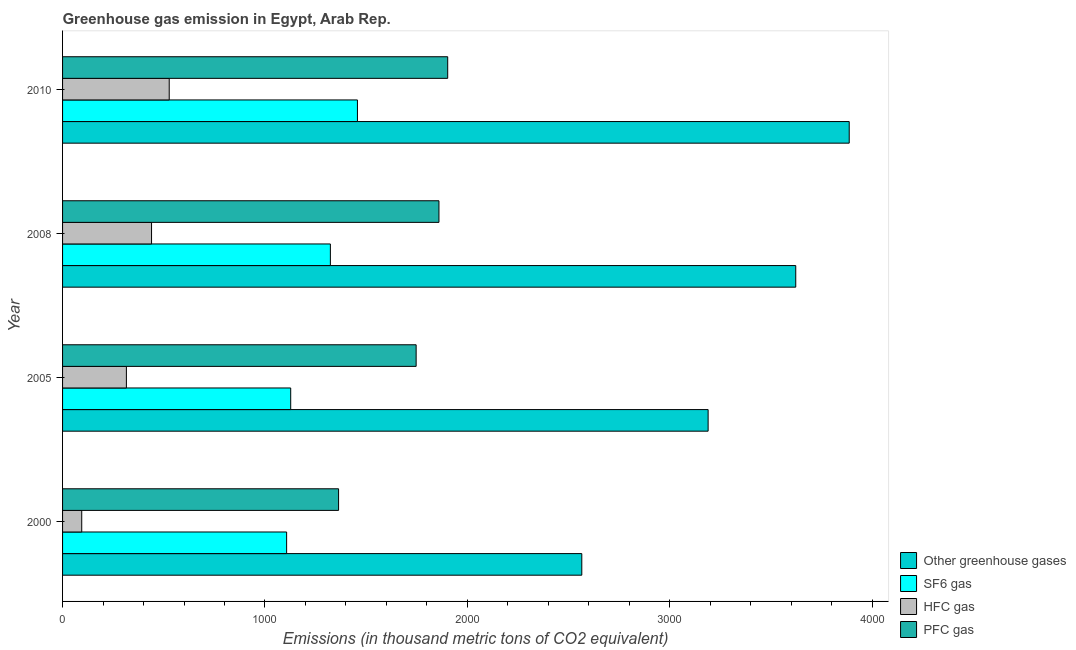How many different coloured bars are there?
Offer a terse response. 4. How many groups of bars are there?
Offer a terse response. 4. Are the number of bars per tick equal to the number of legend labels?
Provide a succinct answer. Yes. How many bars are there on the 1st tick from the top?
Your answer should be compact. 4. What is the label of the 3rd group of bars from the top?
Your answer should be compact. 2005. In how many cases, is the number of bars for a given year not equal to the number of legend labels?
Offer a very short reply. 0. What is the emission of greenhouse gases in 2010?
Make the answer very short. 3887. Across all years, what is the maximum emission of pfc gas?
Provide a short and direct response. 1903. Across all years, what is the minimum emission of greenhouse gases?
Offer a terse response. 2565.6. In which year was the emission of hfc gas maximum?
Ensure brevity in your answer.  2010. What is the total emission of sf6 gas in the graph?
Make the answer very short. 5014.7. What is the difference between the emission of greenhouse gases in 2008 and that in 2010?
Give a very brief answer. -264.2. What is the difference between the emission of greenhouse gases in 2010 and the emission of pfc gas in 2008?
Give a very brief answer. 2027.2. What is the average emission of sf6 gas per year?
Provide a short and direct response. 1253.67. In the year 2005, what is the difference between the emission of hfc gas and emission of sf6 gas?
Keep it short and to the point. -811.9. In how many years, is the emission of greenhouse gases greater than 400 thousand metric tons?
Offer a terse response. 4. What is the ratio of the emission of hfc gas in 2000 to that in 2005?
Offer a terse response. 0.3. What is the difference between the highest and the second highest emission of greenhouse gases?
Keep it short and to the point. 264.2. What is the difference between the highest and the lowest emission of pfc gas?
Ensure brevity in your answer.  539.2. Is the sum of the emission of pfc gas in 2005 and 2008 greater than the maximum emission of sf6 gas across all years?
Your answer should be compact. Yes. Is it the case that in every year, the sum of the emission of greenhouse gases and emission of pfc gas is greater than the sum of emission of hfc gas and emission of sf6 gas?
Offer a terse response. Yes. What does the 4th bar from the top in 2000 represents?
Your answer should be compact. Other greenhouse gases. What does the 2nd bar from the bottom in 2005 represents?
Make the answer very short. SF6 gas. Are all the bars in the graph horizontal?
Your response must be concise. Yes. How many years are there in the graph?
Offer a terse response. 4. Are the values on the major ticks of X-axis written in scientific E-notation?
Provide a short and direct response. No. How are the legend labels stacked?
Your answer should be very brief. Vertical. What is the title of the graph?
Give a very brief answer. Greenhouse gas emission in Egypt, Arab Rep. What is the label or title of the X-axis?
Offer a terse response. Emissions (in thousand metric tons of CO2 equivalent). What is the Emissions (in thousand metric tons of CO2 equivalent) in Other greenhouse gases in 2000?
Make the answer very short. 2565.6. What is the Emissions (in thousand metric tons of CO2 equivalent) in SF6 gas in 2000?
Offer a very short reply. 1107.1. What is the Emissions (in thousand metric tons of CO2 equivalent) of HFC gas in 2000?
Make the answer very short. 94.7. What is the Emissions (in thousand metric tons of CO2 equivalent) in PFC gas in 2000?
Offer a terse response. 1363.8. What is the Emissions (in thousand metric tons of CO2 equivalent) in Other greenhouse gases in 2005?
Provide a short and direct response. 3189.8. What is the Emissions (in thousand metric tons of CO2 equivalent) of SF6 gas in 2005?
Your answer should be compact. 1127.3. What is the Emissions (in thousand metric tons of CO2 equivalent) of HFC gas in 2005?
Your answer should be compact. 315.4. What is the Emissions (in thousand metric tons of CO2 equivalent) in PFC gas in 2005?
Keep it short and to the point. 1747.1. What is the Emissions (in thousand metric tons of CO2 equivalent) of Other greenhouse gases in 2008?
Keep it short and to the point. 3622.8. What is the Emissions (in thousand metric tons of CO2 equivalent) of SF6 gas in 2008?
Offer a very short reply. 1323.3. What is the Emissions (in thousand metric tons of CO2 equivalent) in HFC gas in 2008?
Offer a terse response. 439.7. What is the Emissions (in thousand metric tons of CO2 equivalent) in PFC gas in 2008?
Offer a terse response. 1859.8. What is the Emissions (in thousand metric tons of CO2 equivalent) in Other greenhouse gases in 2010?
Keep it short and to the point. 3887. What is the Emissions (in thousand metric tons of CO2 equivalent) of SF6 gas in 2010?
Ensure brevity in your answer.  1457. What is the Emissions (in thousand metric tons of CO2 equivalent) of HFC gas in 2010?
Give a very brief answer. 527. What is the Emissions (in thousand metric tons of CO2 equivalent) of PFC gas in 2010?
Provide a succinct answer. 1903. Across all years, what is the maximum Emissions (in thousand metric tons of CO2 equivalent) in Other greenhouse gases?
Keep it short and to the point. 3887. Across all years, what is the maximum Emissions (in thousand metric tons of CO2 equivalent) of SF6 gas?
Make the answer very short. 1457. Across all years, what is the maximum Emissions (in thousand metric tons of CO2 equivalent) of HFC gas?
Provide a succinct answer. 527. Across all years, what is the maximum Emissions (in thousand metric tons of CO2 equivalent) of PFC gas?
Keep it short and to the point. 1903. Across all years, what is the minimum Emissions (in thousand metric tons of CO2 equivalent) in Other greenhouse gases?
Give a very brief answer. 2565.6. Across all years, what is the minimum Emissions (in thousand metric tons of CO2 equivalent) in SF6 gas?
Your answer should be very brief. 1107.1. Across all years, what is the minimum Emissions (in thousand metric tons of CO2 equivalent) of HFC gas?
Provide a succinct answer. 94.7. Across all years, what is the minimum Emissions (in thousand metric tons of CO2 equivalent) of PFC gas?
Your answer should be compact. 1363.8. What is the total Emissions (in thousand metric tons of CO2 equivalent) of Other greenhouse gases in the graph?
Provide a succinct answer. 1.33e+04. What is the total Emissions (in thousand metric tons of CO2 equivalent) in SF6 gas in the graph?
Your answer should be very brief. 5014.7. What is the total Emissions (in thousand metric tons of CO2 equivalent) in HFC gas in the graph?
Provide a succinct answer. 1376.8. What is the total Emissions (in thousand metric tons of CO2 equivalent) in PFC gas in the graph?
Your answer should be compact. 6873.7. What is the difference between the Emissions (in thousand metric tons of CO2 equivalent) in Other greenhouse gases in 2000 and that in 2005?
Ensure brevity in your answer.  -624.2. What is the difference between the Emissions (in thousand metric tons of CO2 equivalent) in SF6 gas in 2000 and that in 2005?
Keep it short and to the point. -20.2. What is the difference between the Emissions (in thousand metric tons of CO2 equivalent) of HFC gas in 2000 and that in 2005?
Keep it short and to the point. -220.7. What is the difference between the Emissions (in thousand metric tons of CO2 equivalent) of PFC gas in 2000 and that in 2005?
Give a very brief answer. -383.3. What is the difference between the Emissions (in thousand metric tons of CO2 equivalent) of Other greenhouse gases in 2000 and that in 2008?
Offer a very short reply. -1057.2. What is the difference between the Emissions (in thousand metric tons of CO2 equivalent) of SF6 gas in 2000 and that in 2008?
Your response must be concise. -216.2. What is the difference between the Emissions (in thousand metric tons of CO2 equivalent) in HFC gas in 2000 and that in 2008?
Your answer should be very brief. -345. What is the difference between the Emissions (in thousand metric tons of CO2 equivalent) of PFC gas in 2000 and that in 2008?
Provide a succinct answer. -496. What is the difference between the Emissions (in thousand metric tons of CO2 equivalent) of Other greenhouse gases in 2000 and that in 2010?
Offer a very short reply. -1321.4. What is the difference between the Emissions (in thousand metric tons of CO2 equivalent) in SF6 gas in 2000 and that in 2010?
Offer a very short reply. -349.9. What is the difference between the Emissions (in thousand metric tons of CO2 equivalent) of HFC gas in 2000 and that in 2010?
Keep it short and to the point. -432.3. What is the difference between the Emissions (in thousand metric tons of CO2 equivalent) in PFC gas in 2000 and that in 2010?
Ensure brevity in your answer.  -539.2. What is the difference between the Emissions (in thousand metric tons of CO2 equivalent) of Other greenhouse gases in 2005 and that in 2008?
Your answer should be compact. -433. What is the difference between the Emissions (in thousand metric tons of CO2 equivalent) in SF6 gas in 2005 and that in 2008?
Offer a terse response. -196. What is the difference between the Emissions (in thousand metric tons of CO2 equivalent) in HFC gas in 2005 and that in 2008?
Offer a very short reply. -124.3. What is the difference between the Emissions (in thousand metric tons of CO2 equivalent) of PFC gas in 2005 and that in 2008?
Ensure brevity in your answer.  -112.7. What is the difference between the Emissions (in thousand metric tons of CO2 equivalent) in Other greenhouse gases in 2005 and that in 2010?
Your answer should be very brief. -697.2. What is the difference between the Emissions (in thousand metric tons of CO2 equivalent) of SF6 gas in 2005 and that in 2010?
Ensure brevity in your answer.  -329.7. What is the difference between the Emissions (in thousand metric tons of CO2 equivalent) in HFC gas in 2005 and that in 2010?
Your response must be concise. -211.6. What is the difference between the Emissions (in thousand metric tons of CO2 equivalent) in PFC gas in 2005 and that in 2010?
Make the answer very short. -155.9. What is the difference between the Emissions (in thousand metric tons of CO2 equivalent) of Other greenhouse gases in 2008 and that in 2010?
Keep it short and to the point. -264.2. What is the difference between the Emissions (in thousand metric tons of CO2 equivalent) in SF6 gas in 2008 and that in 2010?
Provide a short and direct response. -133.7. What is the difference between the Emissions (in thousand metric tons of CO2 equivalent) in HFC gas in 2008 and that in 2010?
Make the answer very short. -87.3. What is the difference between the Emissions (in thousand metric tons of CO2 equivalent) in PFC gas in 2008 and that in 2010?
Keep it short and to the point. -43.2. What is the difference between the Emissions (in thousand metric tons of CO2 equivalent) of Other greenhouse gases in 2000 and the Emissions (in thousand metric tons of CO2 equivalent) of SF6 gas in 2005?
Your answer should be compact. 1438.3. What is the difference between the Emissions (in thousand metric tons of CO2 equivalent) of Other greenhouse gases in 2000 and the Emissions (in thousand metric tons of CO2 equivalent) of HFC gas in 2005?
Your answer should be very brief. 2250.2. What is the difference between the Emissions (in thousand metric tons of CO2 equivalent) of Other greenhouse gases in 2000 and the Emissions (in thousand metric tons of CO2 equivalent) of PFC gas in 2005?
Keep it short and to the point. 818.5. What is the difference between the Emissions (in thousand metric tons of CO2 equivalent) of SF6 gas in 2000 and the Emissions (in thousand metric tons of CO2 equivalent) of HFC gas in 2005?
Your answer should be very brief. 791.7. What is the difference between the Emissions (in thousand metric tons of CO2 equivalent) of SF6 gas in 2000 and the Emissions (in thousand metric tons of CO2 equivalent) of PFC gas in 2005?
Your response must be concise. -640. What is the difference between the Emissions (in thousand metric tons of CO2 equivalent) in HFC gas in 2000 and the Emissions (in thousand metric tons of CO2 equivalent) in PFC gas in 2005?
Provide a succinct answer. -1652.4. What is the difference between the Emissions (in thousand metric tons of CO2 equivalent) in Other greenhouse gases in 2000 and the Emissions (in thousand metric tons of CO2 equivalent) in SF6 gas in 2008?
Keep it short and to the point. 1242.3. What is the difference between the Emissions (in thousand metric tons of CO2 equivalent) in Other greenhouse gases in 2000 and the Emissions (in thousand metric tons of CO2 equivalent) in HFC gas in 2008?
Give a very brief answer. 2125.9. What is the difference between the Emissions (in thousand metric tons of CO2 equivalent) in Other greenhouse gases in 2000 and the Emissions (in thousand metric tons of CO2 equivalent) in PFC gas in 2008?
Provide a succinct answer. 705.8. What is the difference between the Emissions (in thousand metric tons of CO2 equivalent) in SF6 gas in 2000 and the Emissions (in thousand metric tons of CO2 equivalent) in HFC gas in 2008?
Your answer should be very brief. 667.4. What is the difference between the Emissions (in thousand metric tons of CO2 equivalent) of SF6 gas in 2000 and the Emissions (in thousand metric tons of CO2 equivalent) of PFC gas in 2008?
Provide a short and direct response. -752.7. What is the difference between the Emissions (in thousand metric tons of CO2 equivalent) in HFC gas in 2000 and the Emissions (in thousand metric tons of CO2 equivalent) in PFC gas in 2008?
Offer a very short reply. -1765.1. What is the difference between the Emissions (in thousand metric tons of CO2 equivalent) of Other greenhouse gases in 2000 and the Emissions (in thousand metric tons of CO2 equivalent) of SF6 gas in 2010?
Provide a short and direct response. 1108.6. What is the difference between the Emissions (in thousand metric tons of CO2 equivalent) in Other greenhouse gases in 2000 and the Emissions (in thousand metric tons of CO2 equivalent) in HFC gas in 2010?
Your answer should be compact. 2038.6. What is the difference between the Emissions (in thousand metric tons of CO2 equivalent) in Other greenhouse gases in 2000 and the Emissions (in thousand metric tons of CO2 equivalent) in PFC gas in 2010?
Give a very brief answer. 662.6. What is the difference between the Emissions (in thousand metric tons of CO2 equivalent) in SF6 gas in 2000 and the Emissions (in thousand metric tons of CO2 equivalent) in HFC gas in 2010?
Provide a short and direct response. 580.1. What is the difference between the Emissions (in thousand metric tons of CO2 equivalent) in SF6 gas in 2000 and the Emissions (in thousand metric tons of CO2 equivalent) in PFC gas in 2010?
Give a very brief answer. -795.9. What is the difference between the Emissions (in thousand metric tons of CO2 equivalent) in HFC gas in 2000 and the Emissions (in thousand metric tons of CO2 equivalent) in PFC gas in 2010?
Your answer should be compact. -1808.3. What is the difference between the Emissions (in thousand metric tons of CO2 equivalent) in Other greenhouse gases in 2005 and the Emissions (in thousand metric tons of CO2 equivalent) in SF6 gas in 2008?
Give a very brief answer. 1866.5. What is the difference between the Emissions (in thousand metric tons of CO2 equivalent) in Other greenhouse gases in 2005 and the Emissions (in thousand metric tons of CO2 equivalent) in HFC gas in 2008?
Ensure brevity in your answer.  2750.1. What is the difference between the Emissions (in thousand metric tons of CO2 equivalent) of Other greenhouse gases in 2005 and the Emissions (in thousand metric tons of CO2 equivalent) of PFC gas in 2008?
Provide a succinct answer. 1330. What is the difference between the Emissions (in thousand metric tons of CO2 equivalent) in SF6 gas in 2005 and the Emissions (in thousand metric tons of CO2 equivalent) in HFC gas in 2008?
Your answer should be compact. 687.6. What is the difference between the Emissions (in thousand metric tons of CO2 equivalent) in SF6 gas in 2005 and the Emissions (in thousand metric tons of CO2 equivalent) in PFC gas in 2008?
Your answer should be very brief. -732.5. What is the difference between the Emissions (in thousand metric tons of CO2 equivalent) of HFC gas in 2005 and the Emissions (in thousand metric tons of CO2 equivalent) of PFC gas in 2008?
Provide a succinct answer. -1544.4. What is the difference between the Emissions (in thousand metric tons of CO2 equivalent) of Other greenhouse gases in 2005 and the Emissions (in thousand metric tons of CO2 equivalent) of SF6 gas in 2010?
Provide a succinct answer. 1732.8. What is the difference between the Emissions (in thousand metric tons of CO2 equivalent) in Other greenhouse gases in 2005 and the Emissions (in thousand metric tons of CO2 equivalent) in HFC gas in 2010?
Provide a succinct answer. 2662.8. What is the difference between the Emissions (in thousand metric tons of CO2 equivalent) in Other greenhouse gases in 2005 and the Emissions (in thousand metric tons of CO2 equivalent) in PFC gas in 2010?
Keep it short and to the point. 1286.8. What is the difference between the Emissions (in thousand metric tons of CO2 equivalent) in SF6 gas in 2005 and the Emissions (in thousand metric tons of CO2 equivalent) in HFC gas in 2010?
Provide a succinct answer. 600.3. What is the difference between the Emissions (in thousand metric tons of CO2 equivalent) of SF6 gas in 2005 and the Emissions (in thousand metric tons of CO2 equivalent) of PFC gas in 2010?
Your answer should be compact. -775.7. What is the difference between the Emissions (in thousand metric tons of CO2 equivalent) of HFC gas in 2005 and the Emissions (in thousand metric tons of CO2 equivalent) of PFC gas in 2010?
Offer a terse response. -1587.6. What is the difference between the Emissions (in thousand metric tons of CO2 equivalent) of Other greenhouse gases in 2008 and the Emissions (in thousand metric tons of CO2 equivalent) of SF6 gas in 2010?
Make the answer very short. 2165.8. What is the difference between the Emissions (in thousand metric tons of CO2 equivalent) in Other greenhouse gases in 2008 and the Emissions (in thousand metric tons of CO2 equivalent) in HFC gas in 2010?
Make the answer very short. 3095.8. What is the difference between the Emissions (in thousand metric tons of CO2 equivalent) in Other greenhouse gases in 2008 and the Emissions (in thousand metric tons of CO2 equivalent) in PFC gas in 2010?
Offer a very short reply. 1719.8. What is the difference between the Emissions (in thousand metric tons of CO2 equivalent) in SF6 gas in 2008 and the Emissions (in thousand metric tons of CO2 equivalent) in HFC gas in 2010?
Your answer should be compact. 796.3. What is the difference between the Emissions (in thousand metric tons of CO2 equivalent) of SF6 gas in 2008 and the Emissions (in thousand metric tons of CO2 equivalent) of PFC gas in 2010?
Make the answer very short. -579.7. What is the difference between the Emissions (in thousand metric tons of CO2 equivalent) in HFC gas in 2008 and the Emissions (in thousand metric tons of CO2 equivalent) in PFC gas in 2010?
Ensure brevity in your answer.  -1463.3. What is the average Emissions (in thousand metric tons of CO2 equivalent) in Other greenhouse gases per year?
Keep it short and to the point. 3316.3. What is the average Emissions (in thousand metric tons of CO2 equivalent) in SF6 gas per year?
Offer a terse response. 1253.67. What is the average Emissions (in thousand metric tons of CO2 equivalent) in HFC gas per year?
Your answer should be very brief. 344.2. What is the average Emissions (in thousand metric tons of CO2 equivalent) of PFC gas per year?
Your answer should be compact. 1718.42. In the year 2000, what is the difference between the Emissions (in thousand metric tons of CO2 equivalent) in Other greenhouse gases and Emissions (in thousand metric tons of CO2 equivalent) in SF6 gas?
Provide a short and direct response. 1458.5. In the year 2000, what is the difference between the Emissions (in thousand metric tons of CO2 equivalent) of Other greenhouse gases and Emissions (in thousand metric tons of CO2 equivalent) of HFC gas?
Your response must be concise. 2470.9. In the year 2000, what is the difference between the Emissions (in thousand metric tons of CO2 equivalent) in Other greenhouse gases and Emissions (in thousand metric tons of CO2 equivalent) in PFC gas?
Your response must be concise. 1201.8. In the year 2000, what is the difference between the Emissions (in thousand metric tons of CO2 equivalent) of SF6 gas and Emissions (in thousand metric tons of CO2 equivalent) of HFC gas?
Offer a terse response. 1012.4. In the year 2000, what is the difference between the Emissions (in thousand metric tons of CO2 equivalent) of SF6 gas and Emissions (in thousand metric tons of CO2 equivalent) of PFC gas?
Give a very brief answer. -256.7. In the year 2000, what is the difference between the Emissions (in thousand metric tons of CO2 equivalent) of HFC gas and Emissions (in thousand metric tons of CO2 equivalent) of PFC gas?
Offer a terse response. -1269.1. In the year 2005, what is the difference between the Emissions (in thousand metric tons of CO2 equivalent) in Other greenhouse gases and Emissions (in thousand metric tons of CO2 equivalent) in SF6 gas?
Provide a succinct answer. 2062.5. In the year 2005, what is the difference between the Emissions (in thousand metric tons of CO2 equivalent) in Other greenhouse gases and Emissions (in thousand metric tons of CO2 equivalent) in HFC gas?
Provide a short and direct response. 2874.4. In the year 2005, what is the difference between the Emissions (in thousand metric tons of CO2 equivalent) in Other greenhouse gases and Emissions (in thousand metric tons of CO2 equivalent) in PFC gas?
Ensure brevity in your answer.  1442.7. In the year 2005, what is the difference between the Emissions (in thousand metric tons of CO2 equivalent) in SF6 gas and Emissions (in thousand metric tons of CO2 equivalent) in HFC gas?
Give a very brief answer. 811.9. In the year 2005, what is the difference between the Emissions (in thousand metric tons of CO2 equivalent) of SF6 gas and Emissions (in thousand metric tons of CO2 equivalent) of PFC gas?
Make the answer very short. -619.8. In the year 2005, what is the difference between the Emissions (in thousand metric tons of CO2 equivalent) of HFC gas and Emissions (in thousand metric tons of CO2 equivalent) of PFC gas?
Offer a terse response. -1431.7. In the year 2008, what is the difference between the Emissions (in thousand metric tons of CO2 equivalent) of Other greenhouse gases and Emissions (in thousand metric tons of CO2 equivalent) of SF6 gas?
Your answer should be very brief. 2299.5. In the year 2008, what is the difference between the Emissions (in thousand metric tons of CO2 equivalent) of Other greenhouse gases and Emissions (in thousand metric tons of CO2 equivalent) of HFC gas?
Your response must be concise. 3183.1. In the year 2008, what is the difference between the Emissions (in thousand metric tons of CO2 equivalent) in Other greenhouse gases and Emissions (in thousand metric tons of CO2 equivalent) in PFC gas?
Make the answer very short. 1763. In the year 2008, what is the difference between the Emissions (in thousand metric tons of CO2 equivalent) in SF6 gas and Emissions (in thousand metric tons of CO2 equivalent) in HFC gas?
Keep it short and to the point. 883.6. In the year 2008, what is the difference between the Emissions (in thousand metric tons of CO2 equivalent) of SF6 gas and Emissions (in thousand metric tons of CO2 equivalent) of PFC gas?
Offer a terse response. -536.5. In the year 2008, what is the difference between the Emissions (in thousand metric tons of CO2 equivalent) of HFC gas and Emissions (in thousand metric tons of CO2 equivalent) of PFC gas?
Keep it short and to the point. -1420.1. In the year 2010, what is the difference between the Emissions (in thousand metric tons of CO2 equivalent) in Other greenhouse gases and Emissions (in thousand metric tons of CO2 equivalent) in SF6 gas?
Offer a terse response. 2430. In the year 2010, what is the difference between the Emissions (in thousand metric tons of CO2 equivalent) of Other greenhouse gases and Emissions (in thousand metric tons of CO2 equivalent) of HFC gas?
Offer a very short reply. 3360. In the year 2010, what is the difference between the Emissions (in thousand metric tons of CO2 equivalent) in Other greenhouse gases and Emissions (in thousand metric tons of CO2 equivalent) in PFC gas?
Offer a terse response. 1984. In the year 2010, what is the difference between the Emissions (in thousand metric tons of CO2 equivalent) in SF6 gas and Emissions (in thousand metric tons of CO2 equivalent) in HFC gas?
Your answer should be compact. 930. In the year 2010, what is the difference between the Emissions (in thousand metric tons of CO2 equivalent) of SF6 gas and Emissions (in thousand metric tons of CO2 equivalent) of PFC gas?
Give a very brief answer. -446. In the year 2010, what is the difference between the Emissions (in thousand metric tons of CO2 equivalent) of HFC gas and Emissions (in thousand metric tons of CO2 equivalent) of PFC gas?
Provide a short and direct response. -1376. What is the ratio of the Emissions (in thousand metric tons of CO2 equivalent) of Other greenhouse gases in 2000 to that in 2005?
Ensure brevity in your answer.  0.8. What is the ratio of the Emissions (in thousand metric tons of CO2 equivalent) in SF6 gas in 2000 to that in 2005?
Your response must be concise. 0.98. What is the ratio of the Emissions (in thousand metric tons of CO2 equivalent) in HFC gas in 2000 to that in 2005?
Your response must be concise. 0.3. What is the ratio of the Emissions (in thousand metric tons of CO2 equivalent) in PFC gas in 2000 to that in 2005?
Your answer should be very brief. 0.78. What is the ratio of the Emissions (in thousand metric tons of CO2 equivalent) of Other greenhouse gases in 2000 to that in 2008?
Your response must be concise. 0.71. What is the ratio of the Emissions (in thousand metric tons of CO2 equivalent) of SF6 gas in 2000 to that in 2008?
Your answer should be compact. 0.84. What is the ratio of the Emissions (in thousand metric tons of CO2 equivalent) in HFC gas in 2000 to that in 2008?
Your answer should be very brief. 0.22. What is the ratio of the Emissions (in thousand metric tons of CO2 equivalent) of PFC gas in 2000 to that in 2008?
Offer a very short reply. 0.73. What is the ratio of the Emissions (in thousand metric tons of CO2 equivalent) in Other greenhouse gases in 2000 to that in 2010?
Ensure brevity in your answer.  0.66. What is the ratio of the Emissions (in thousand metric tons of CO2 equivalent) in SF6 gas in 2000 to that in 2010?
Provide a succinct answer. 0.76. What is the ratio of the Emissions (in thousand metric tons of CO2 equivalent) of HFC gas in 2000 to that in 2010?
Keep it short and to the point. 0.18. What is the ratio of the Emissions (in thousand metric tons of CO2 equivalent) of PFC gas in 2000 to that in 2010?
Provide a succinct answer. 0.72. What is the ratio of the Emissions (in thousand metric tons of CO2 equivalent) in Other greenhouse gases in 2005 to that in 2008?
Offer a very short reply. 0.88. What is the ratio of the Emissions (in thousand metric tons of CO2 equivalent) in SF6 gas in 2005 to that in 2008?
Provide a short and direct response. 0.85. What is the ratio of the Emissions (in thousand metric tons of CO2 equivalent) in HFC gas in 2005 to that in 2008?
Your answer should be very brief. 0.72. What is the ratio of the Emissions (in thousand metric tons of CO2 equivalent) of PFC gas in 2005 to that in 2008?
Ensure brevity in your answer.  0.94. What is the ratio of the Emissions (in thousand metric tons of CO2 equivalent) of Other greenhouse gases in 2005 to that in 2010?
Give a very brief answer. 0.82. What is the ratio of the Emissions (in thousand metric tons of CO2 equivalent) of SF6 gas in 2005 to that in 2010?
Provide a succinct answer. 0.77. What is the ratio of the Emissions (in thousand metric tons of CO2 equivalent) in HFC gas in 2005 to that in 2010?
Offer a terse response. 0.6. What is the ratio of the Emissions (in thousand metric tons of CO2 equivalent) in PFC gas in 2005 to that in 2010?
Make the answer very short. 0.92. What is the ratio of the Emissions (in thousand metric tons of CO2 equivalent) in Other greenhouse gases in 2008 to that in 2010?
Provide a succinct answer. 0.93. What is the ratio of the Emissions (in thousand metric tons of CO2 equivalent) of SF6 gas in 2008 to that in 2010?
Provide a short and direct response. 0.91. What is the ratio of the Emissions (in thousand metric tons of CO2 equivalent) in HFC gas in 2008 to that in 2010?
Your response must be concise. 0.83. What is the ratio of the Emissions (in thousand metric tons of CO2 equivalent) of PFC gas in 2008 to that in 2010?
Keep it short and to the point. 0.98. What is the difference between the highest and the second highest Emissions (in thousand metric tons of CO2 equivalent) in Other greenhouse gases?
Give a very brief answer. 264.2. What is the difference between the highest and the second highest Emissions (in thousand metric tons of CO2 equivalent) of SF6 gas?
Your response must be concise. 133.7. What is the difference between the highest and the second highest Emissions (in thousand metric tons of CO2 equivalent) in HFC gas?
Ensure brevity in your answer.  87.3. What is the difference between the highest and the second highest Emissions (in thousand metric tons of CO2 equivalent) of PFC gas?
Provide a succinct answer. 43.2. What is the difference between the highest and the lowest Emissions (in thousand metric tons of CO2 equivalent) of Other greenhouse gases?
Provide a short and direct response. 1321.4. What is the difference between the highest and the lowest Emissions (in thousand metric tons of CO2 equivalent) of SF6 gas?
Your answer should be very brief. 349.9. What is the difference between the highest and the lowest Emissions (in thousand metric tons of CO2 equivalent) in HFC gas?
Ensure brevity in your answer.  432.3. What is the difference between the highest and the lowest Emissions (in thousand metric tons of CO2 equivalent) of PFC gas?
Provide a succinct answer. 539.2. 